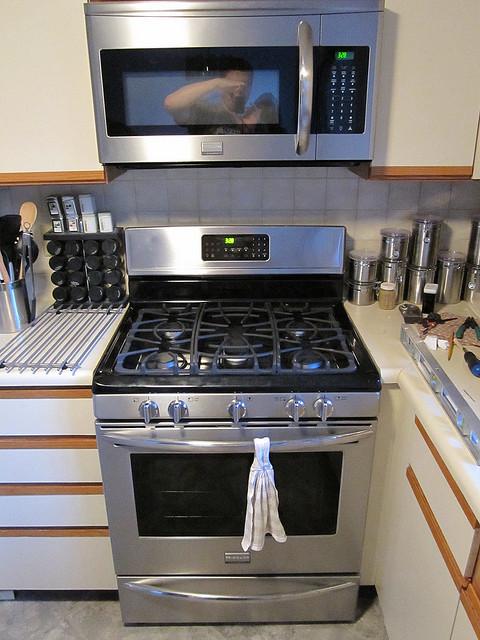What typical beverage can be made by the instrument on the stove top?
Answer briefly. Tea. What room of the house is this?
Write a very short answer. Kitchen. What material is the stove made of?
Short answer required. Stainless steel. What is above the stove?
Keep it brief. Microwave. 